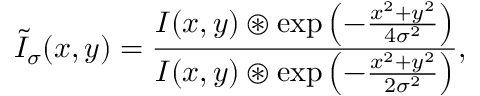Convert formula to latex. <formula><loc_0><loc_0><loc_500><loc_500>\widetilde { I } _ { \sigma } ( x , y ) = \frac { I ( x , y ) \circledast \exp \left ( - \frac { x ^ { 2 } + y ^ { 2 } } { 4 \sigma ^ { 2 } } \right ) } { I ( x , y ) \circledast \exp \left ( - \frac { x ^ { 2 } + y ^ { 2 } } { 2 \sigma ^ { 2 } } \right ) } ,</formula> 